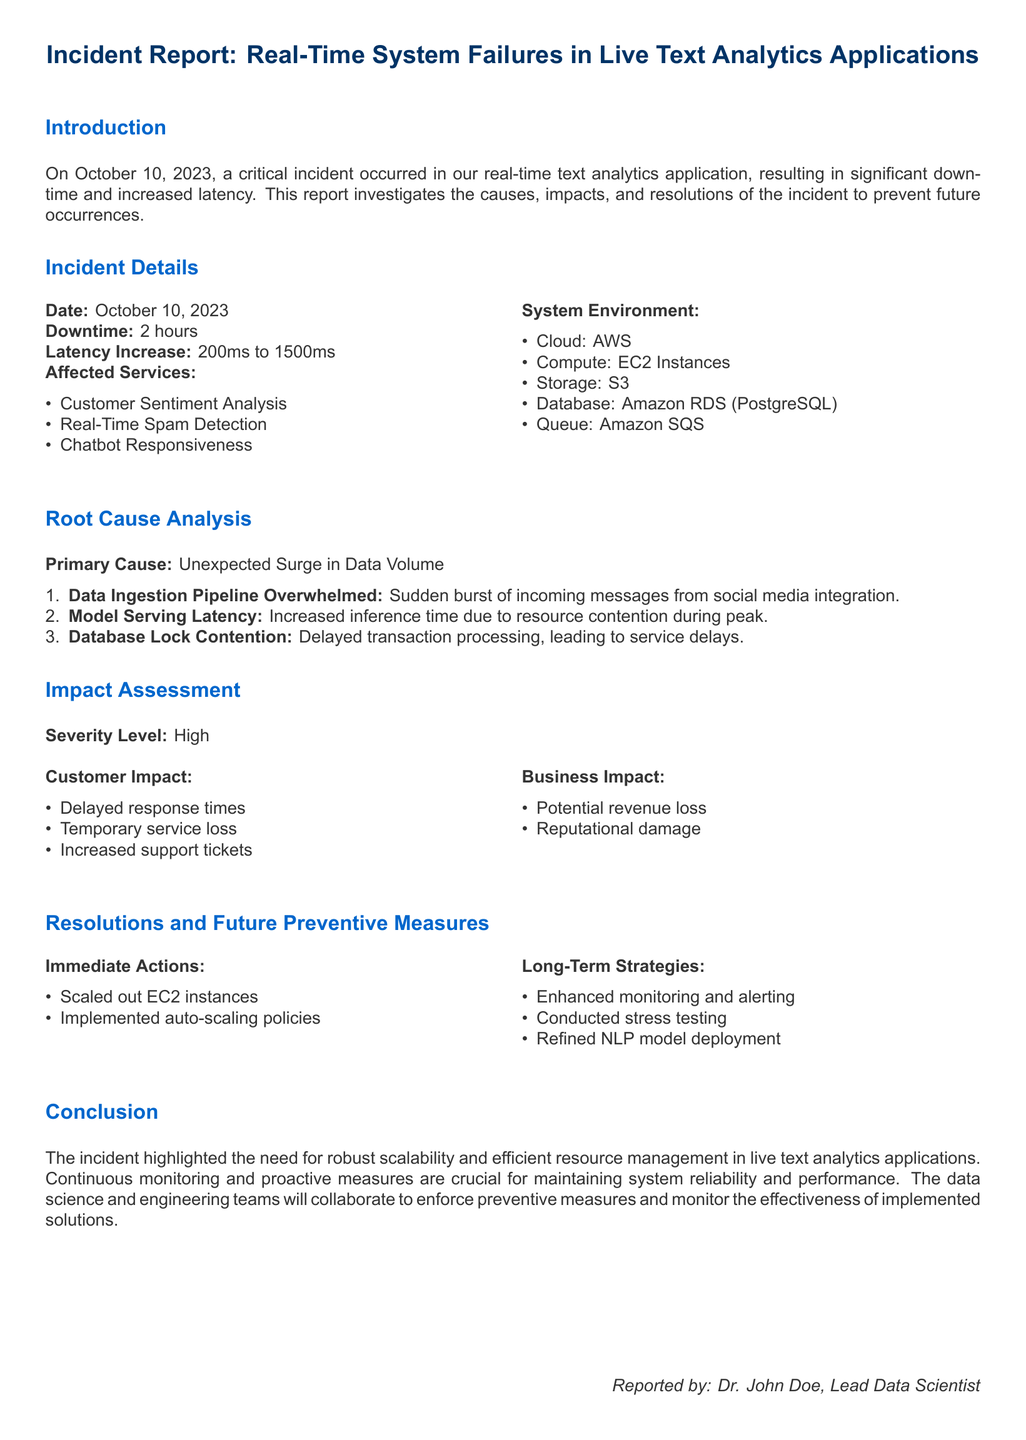what was the date of the incident? The incident occurred on October 10, 2023, as stated in the document.
Answer: October 10, 2023 how long was the downtime? The document specifies that the downtime lasted for 2 hours.
Answer: 2 hours what was the latency increase? According to the report, latency increased from 200ms to 1500ms.
Answer: 200ms to 1500ms what was the primary cause of the incident? The report identifies "Unexpected Surge in Data Volume" as the primary cause of the incident.
Answer: Unexpected Surge in Data Volume which service experienced delayed response times? The incident report lists "Customer Sentiment Analysis" as one of the affected services.
Answer: Customer Sentiment Analysis what immediate actions were taken? The document mentions "Scaled out EC2 instances" as an immediate action taken to resolve the issues.
Answer: Scaled out EC2 instances what was the severity level of the incident? The severity level is rated as high in the impact assessment section.
Answer: High what long-term strategy was suggested for future prevention? The report recommends "Enhanced monitoring and alerting" as a long-term strategy.
Answer: Enhanced monitoring and alerting how many affected services are listed? Three affected services are enumerated in the document.
Answer: Three 